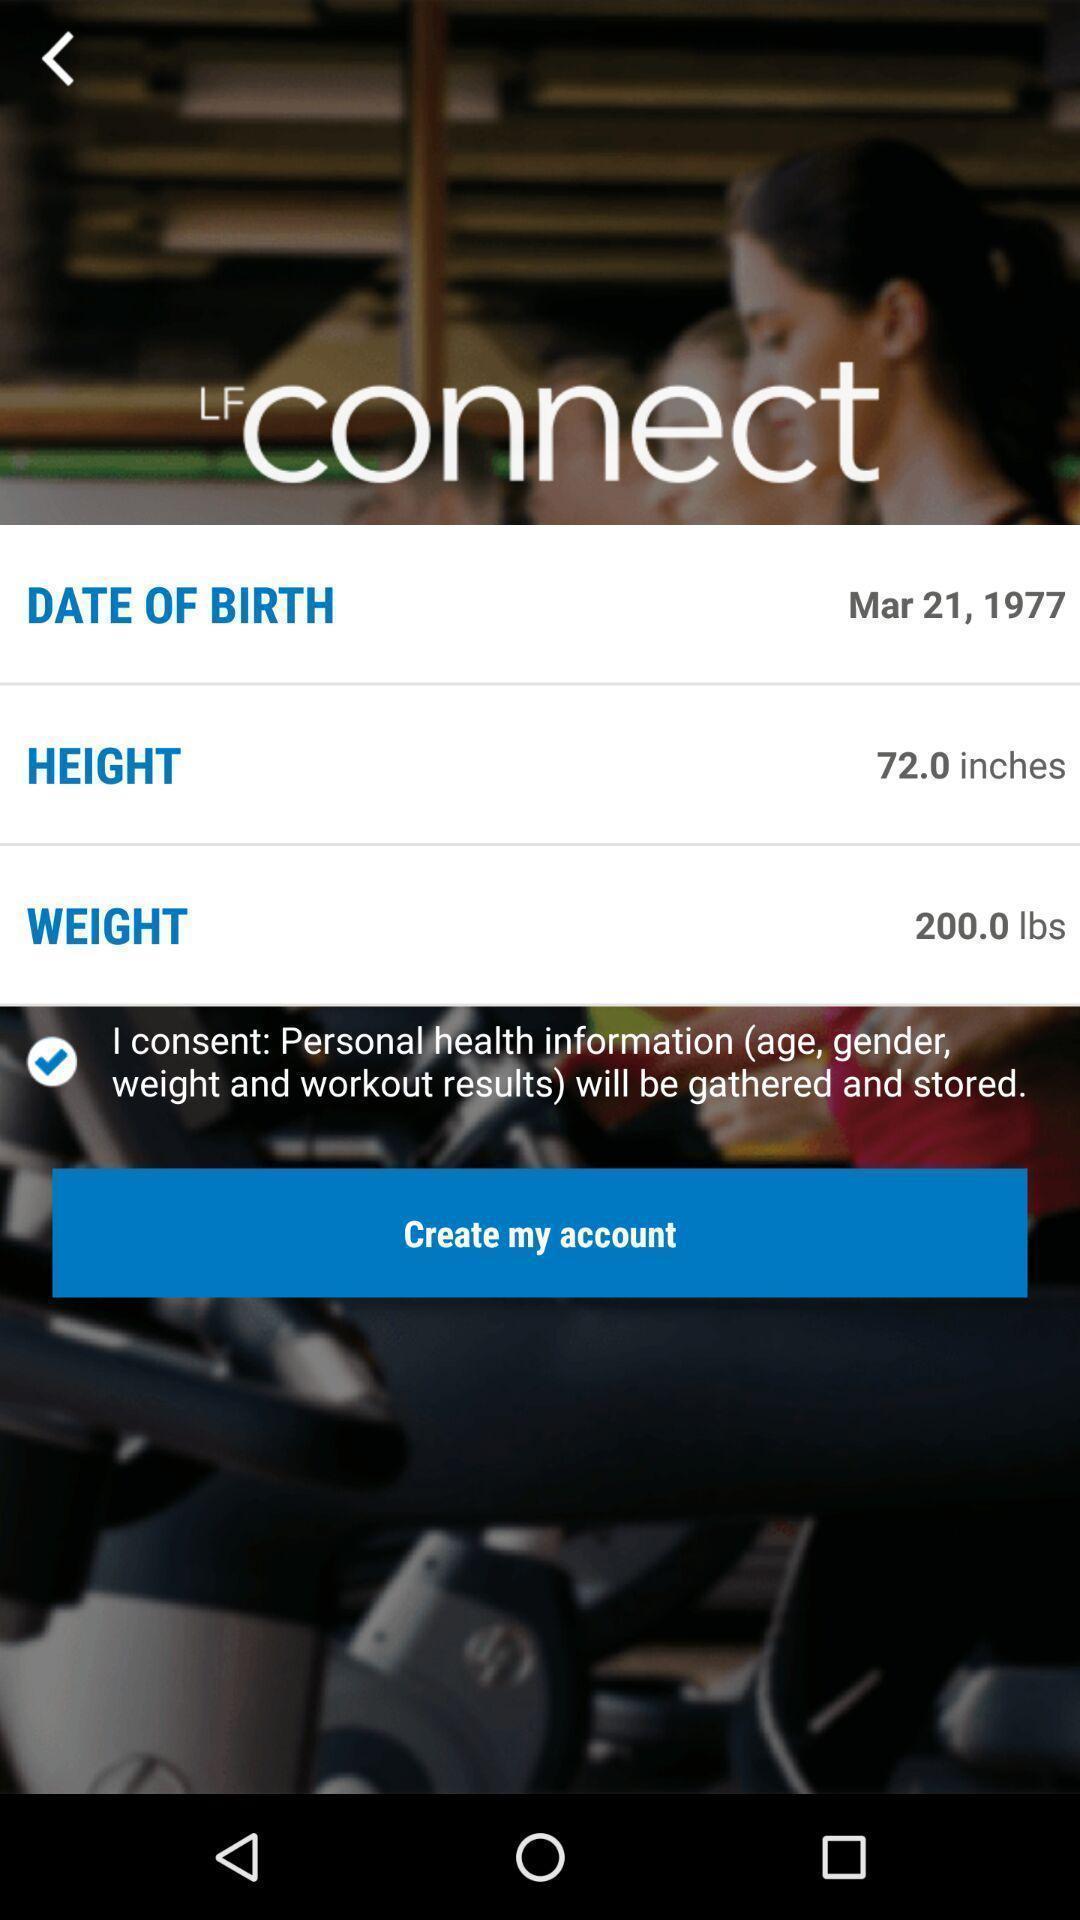Describe the content in this image. Screen shows to create account for fitness app. 